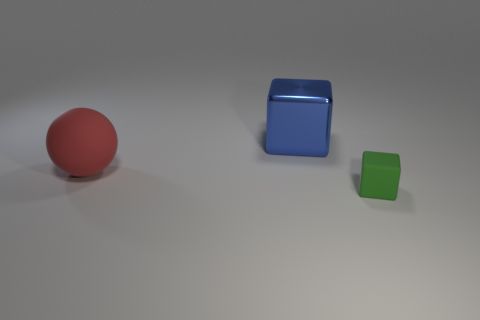Subtract all green cubes. How many cubes are left? 1 Subtract all spheres. How many objects are left? 2 Add 2 tiny blocks. How many objects exist? 5 Subtract all cyan spheres. How many blue blocks are left? 1 Subtract all tiny green cubes. Subtract all green rubber things. How many objects are left? 1 Add 3 tiny green cubes. How many tiny green cubes are left? 4 Add 2 yellow metal objects. How many yellow metal objects exist? 2 Subtract 0 brown blocks. How many objects are left? 3 Subtract all brown cubes. Subtract all blue spheres. How many cubes are left? 2 